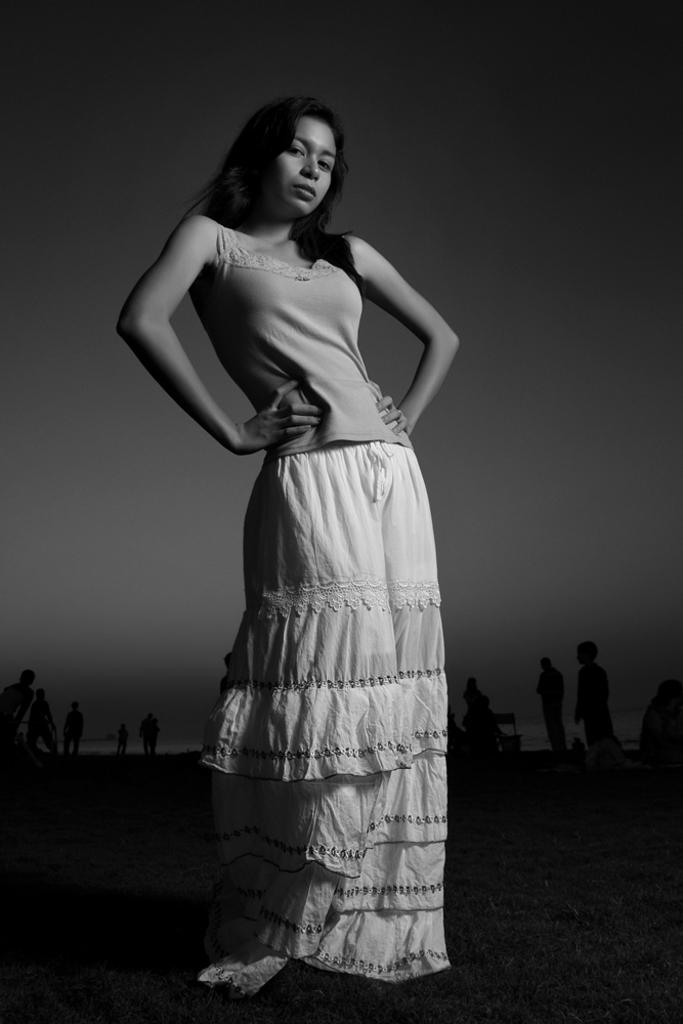What is the color scheme of the image? The image is black and white. What is the woman in the image doing? The woman is standing on the ground in the image. Can you describe the background of the image? There are people standing in the background of the image, and the sky is visible. What type of quartz can be seen in the woman's hand in the image? There is no quartz present in the image; it is a black and white image with a woman standing on the ground and people in the background. 